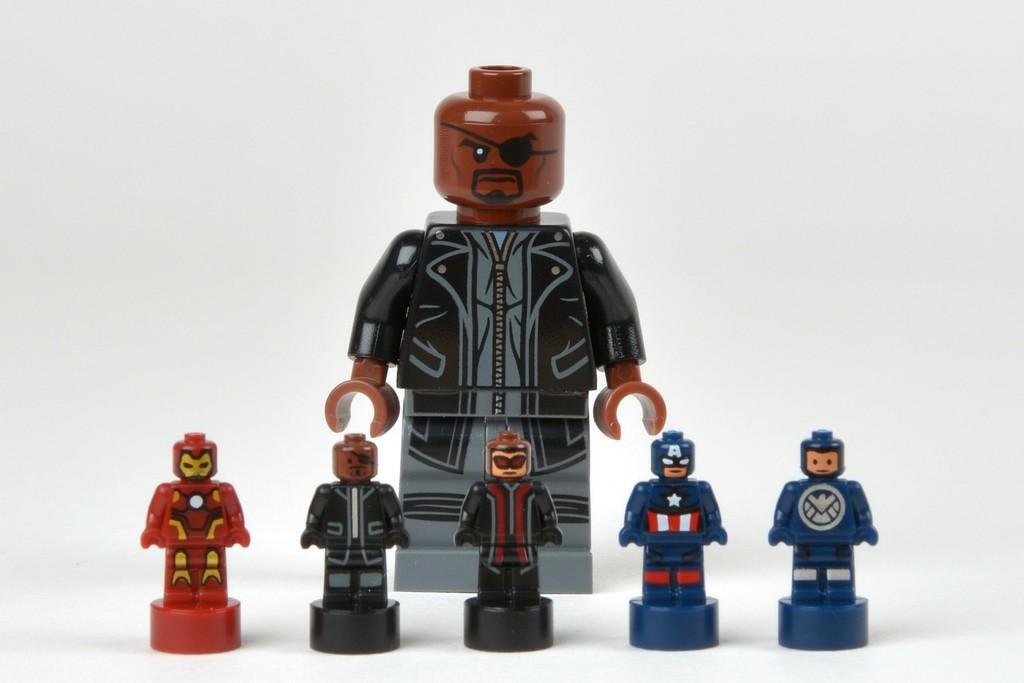Could you give a brief overview of what you see in this image? In this picture we can see six toys on a platform and in the background it is white color. 